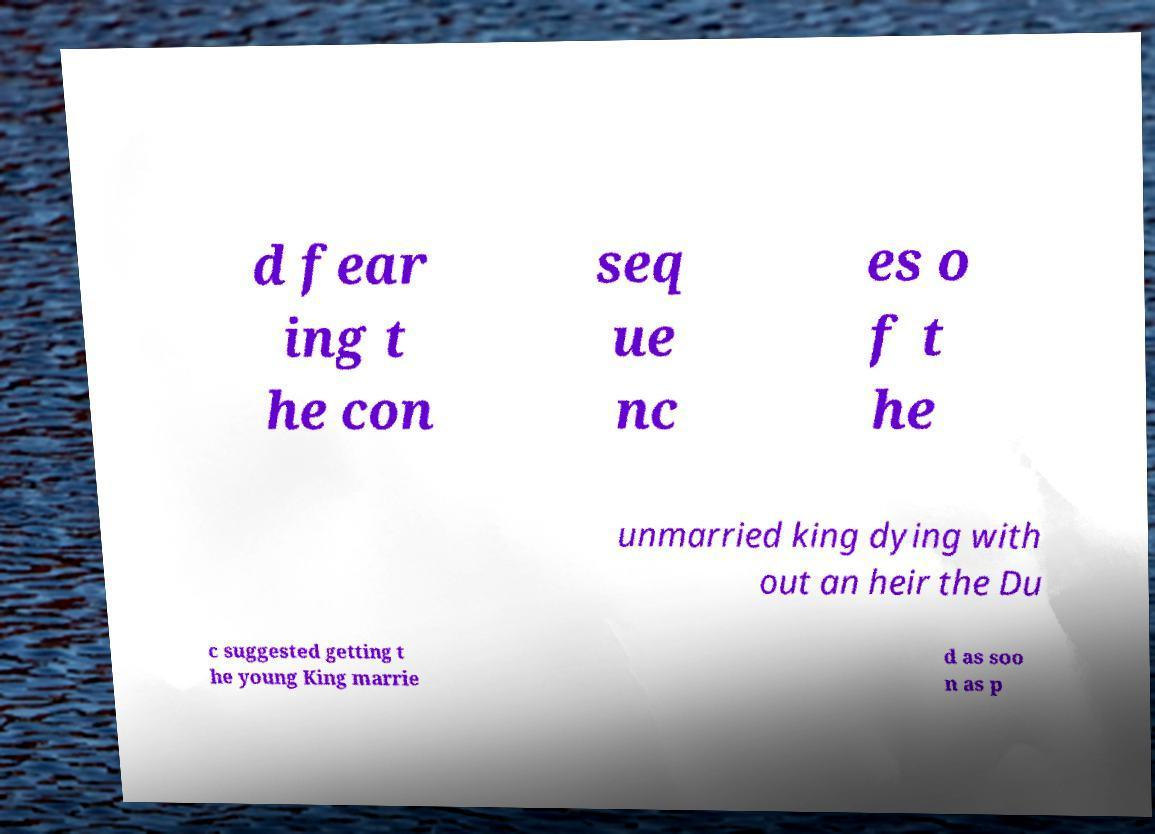Please read and relay the text visible in this image. What does it say? d fear ing t he con seq ue nc es o f t he unmarried king dying with out an heir the Du c suggested getting t he young King marrie d as soo n as p 